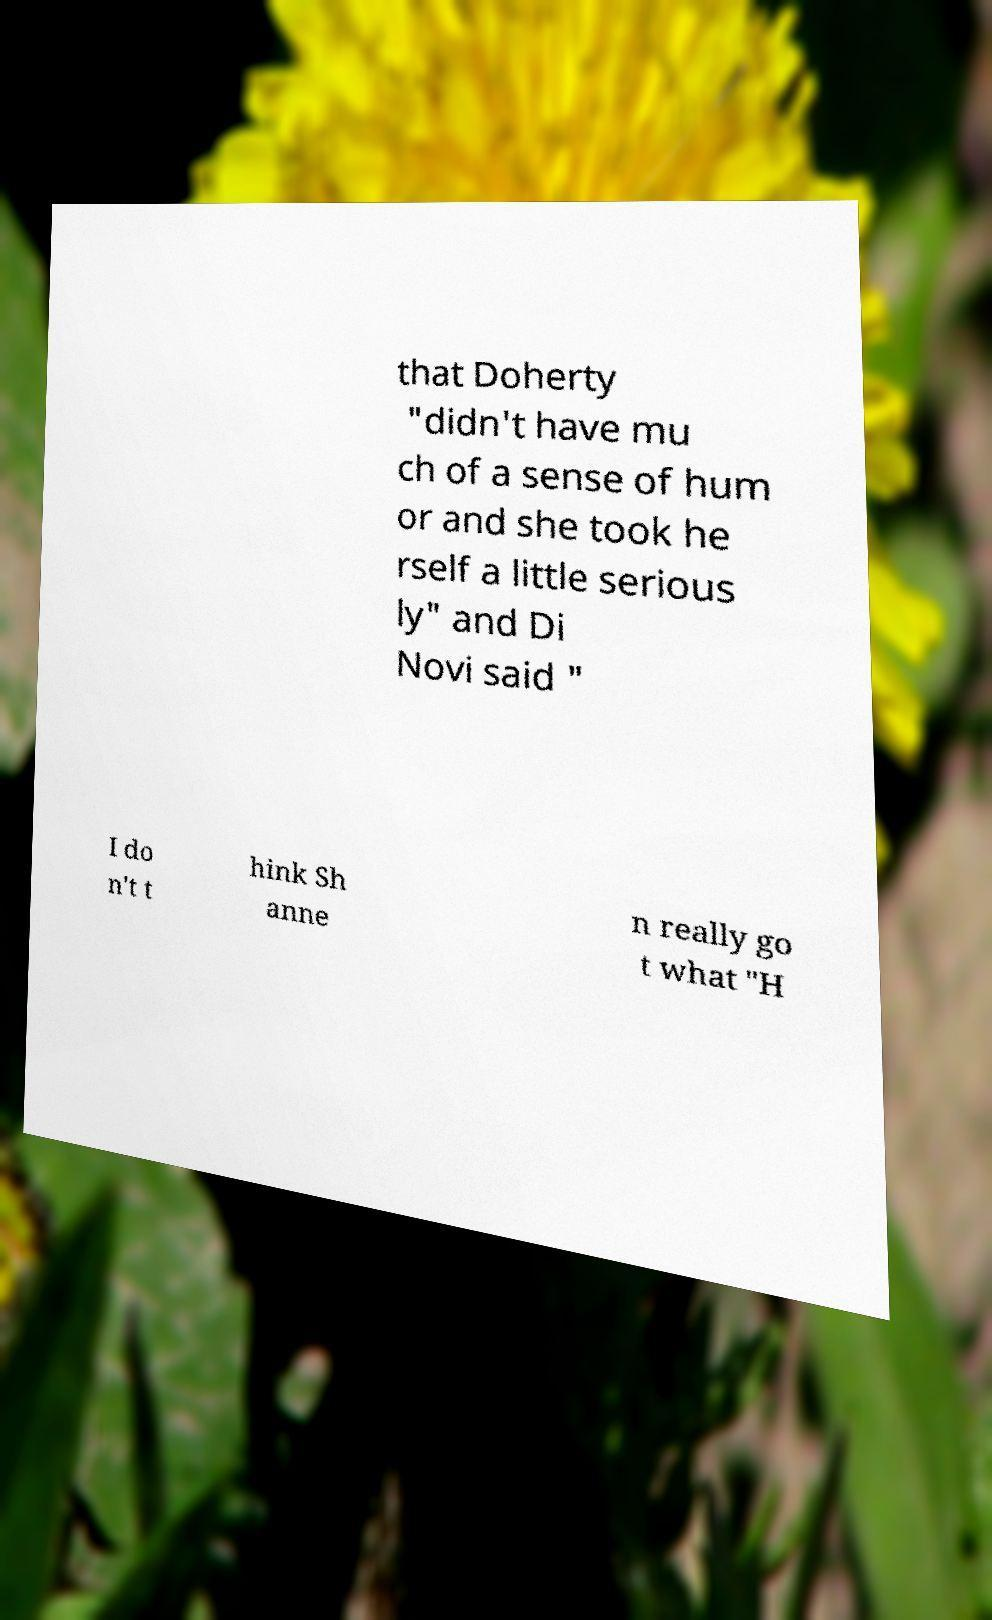Could you extract and type out the text from this image? that Doherty "didn't have mu ch of a sense of hum or and she took he rself a little serious ly" and Di Novi said " I do n't t hink Sh anne n really go t what "H 